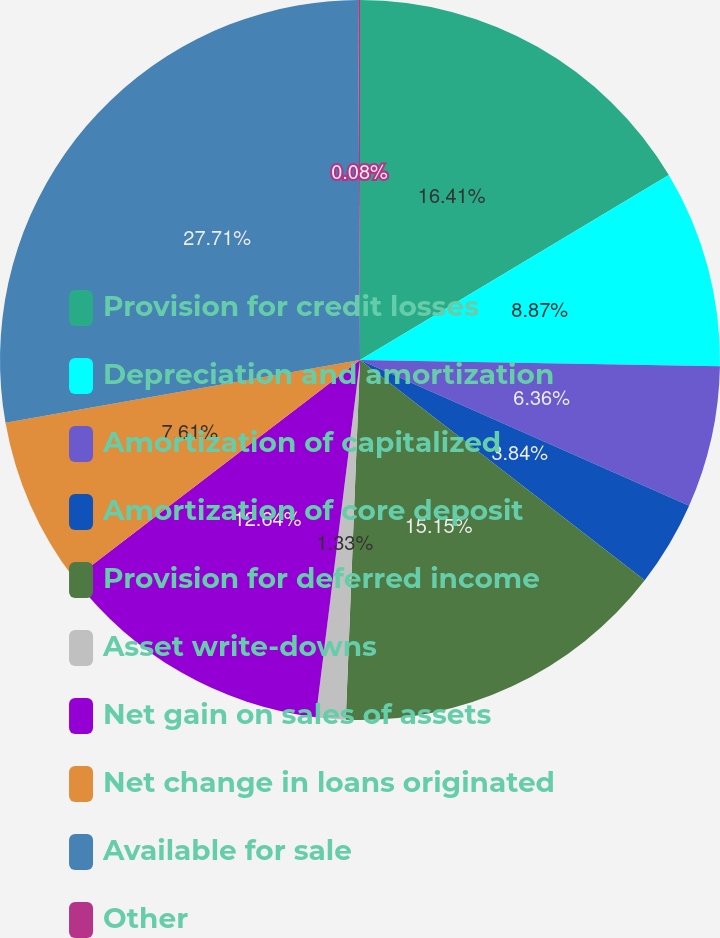<chart> <loc_0><loc_0><loc_500><loc_500><pie_chart><fcel>Provision for credit losses<fcel>Depreciation and amortization<fcel>Amortization of capitalized<fcel>Amortization of core deposit<fcel>Provision for deferred income<fcel>Asset write-downs<fcel>Net gain on sales of assets<fcel>Net change in loans originated<fcel>Available for sale<fcel>Other<nl><fcel>16.41%<fcel>8.87%<fcel>6.36%<fcel>3.84%<fcel>15.15%<fcel>1.33%<fcel>12.64%<fcel>7.61%<fcel>27.71%<fcel>0.08%<nl></chart> 